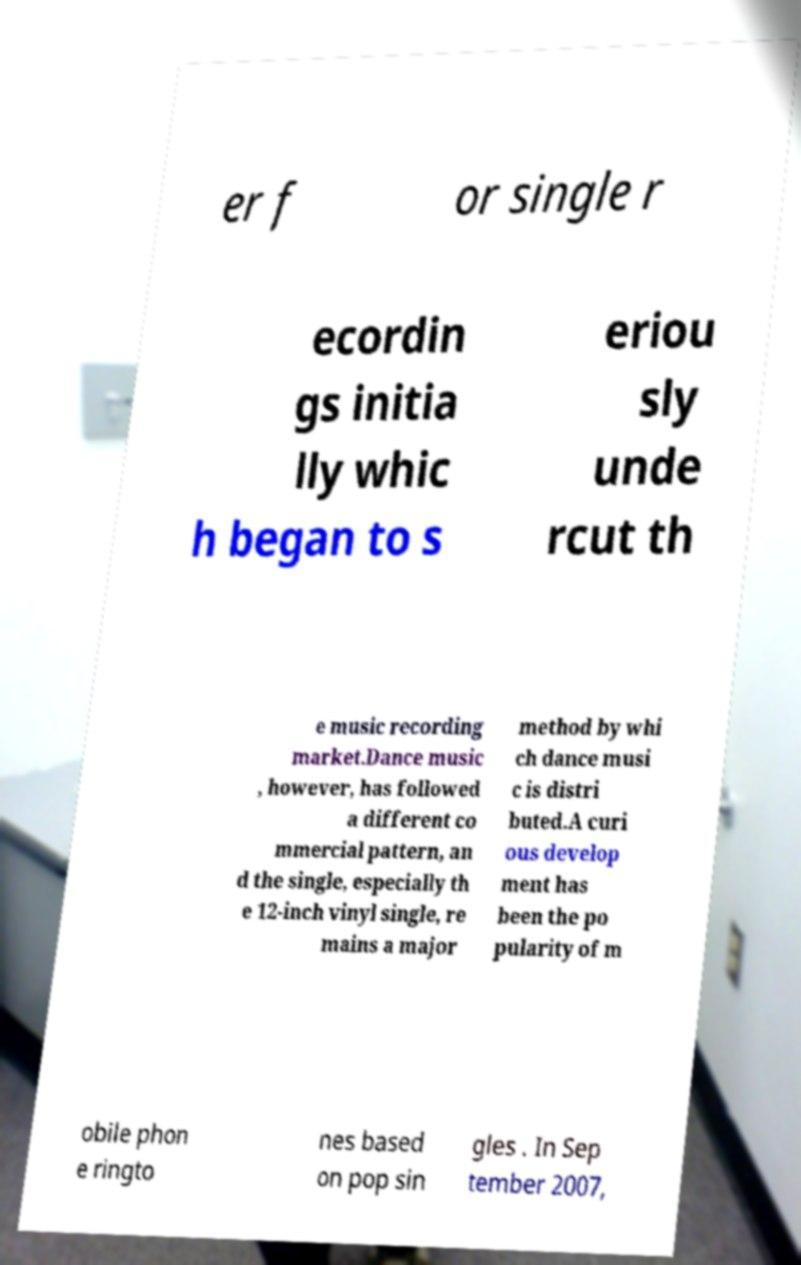I need the written content from this picture converted into text. Can you do that? er f or single r ecordin gs initia lly whic h began to s eriou sly unde rcut th e music recording market.Dance music , however, has followed a different co mmercial pattern, an d the single, especially th e 12-inch vinyl single, re mains a major method by whi ch dance musi c is distri buted.A curi ous develop ment has been the po pularity of m obile phon e ringto nes based on pop sin gles . In Sep tember 2007, 